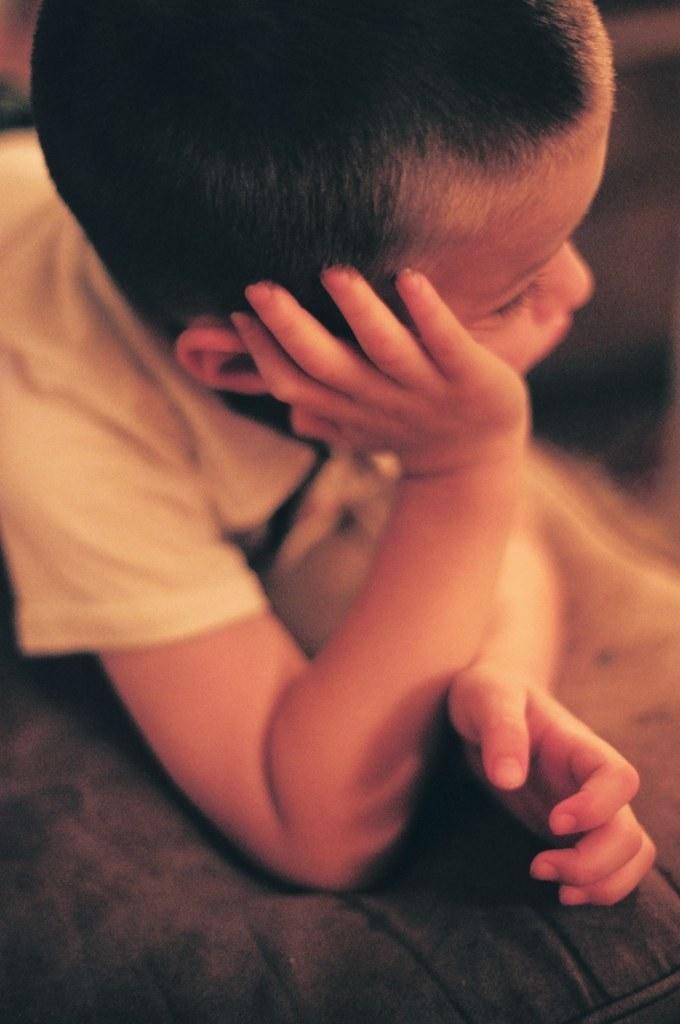How would you summarize this image in a sentence or two? In the image there is a boy. 